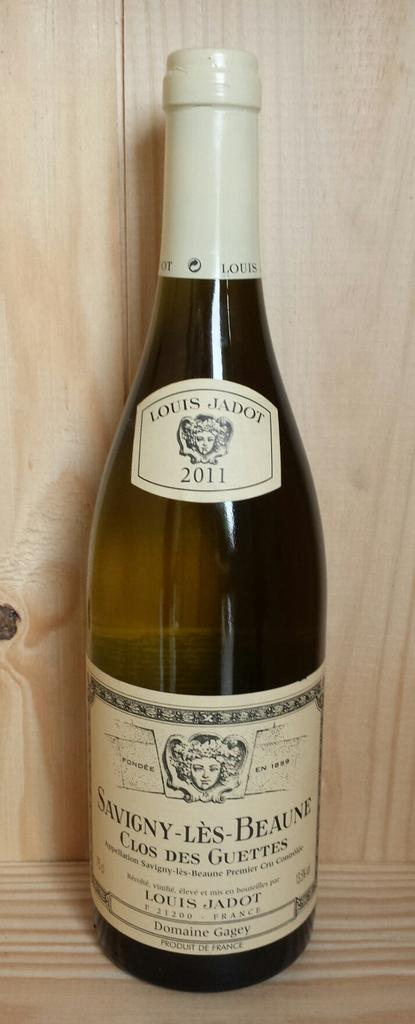<image>
Present a compact description of the photo's key features. A wine bottle of Savingy-Les Beaune sits in front of a wooden wall. 